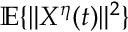Convert formula to latex. <formula><loc_0><loc_0><loc_500><loc_500>\mathbb { E } \{ \| X ^ { \eta } ( t ) \| ^ { 2 } \}</formula> 